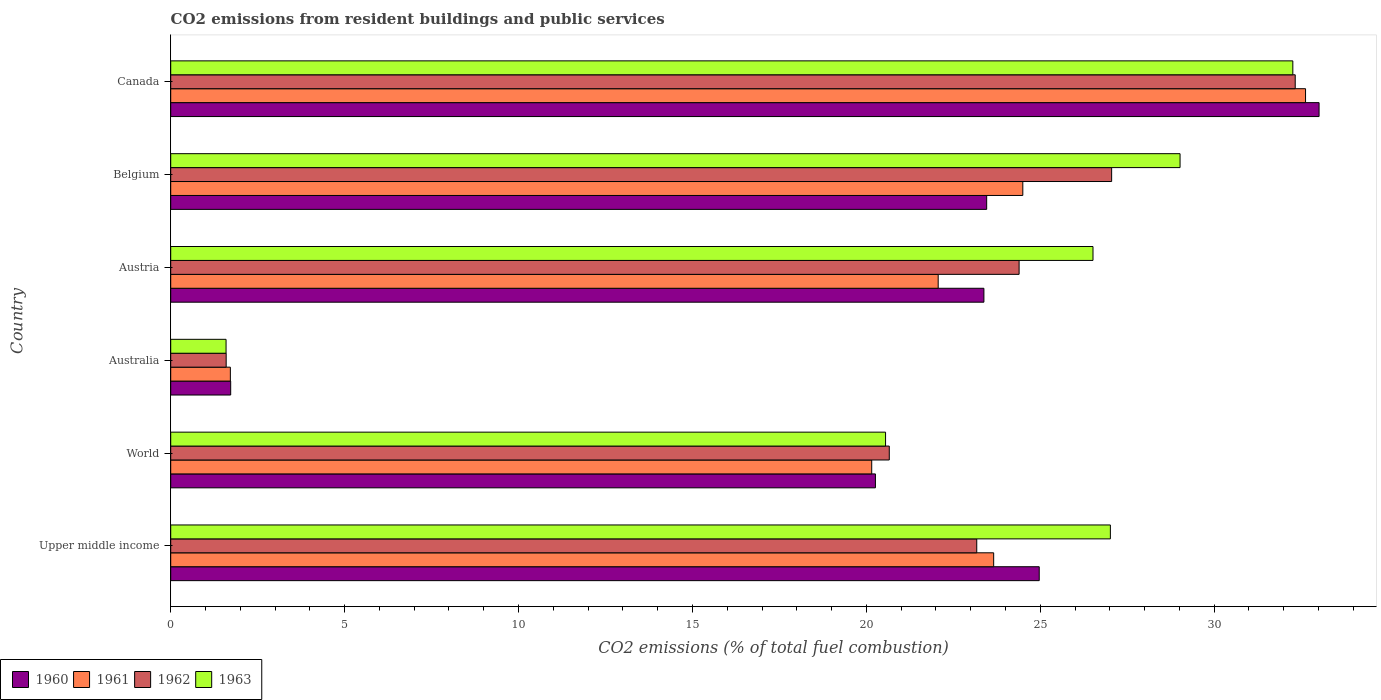How many different coloured bars are there?
Your answer should be compact. 4. How many groups of bars are there?
Provide a succinct answer. 6. Are the number of bars on each tick of the Y-axis equal?
Provide a short and direct response. Yes. How many bars are there on the 1st tick from the top?
Offer a terse response. 4. How many bars are there on the 4th tick from the bottom?
Your response must be concise. 4. What is the total CO2 emitted in 1963 in Canada?
Provide a short and direct response. 32.26. Across all countries, what is the maximum total CO2 emitted in 1961?
Give a very brief answer. 32.63. Across all countries, what is the minimum total CO2 emitted in 1961?
Make the answer very short. 1.71. In which country was the total CO2 emitted in 1961 minimum?
Your answer should be compact. Australia. What is the total total CO2 emitted in 1960 in the graph?
Your answer should be very brief. 126.81. What is the difference between the total CO2 emitted in 1961 in Austria and that in Canada?
Your answer should be very brief. -10.56. What is the difference between the total CO2 emitted in 1961 in Australia and the total CO2 emitted in 1962 in Canada?
Ensure brevity in your answer.  -30.61. What is the average total CO2 emitted in 1960 per country?
Offer a terse response. 21.13. What is the difference between the total CO2 emitted in 1963 and total CO2 emitted in 1960 in Upper middle income?
Give a very brief answer. 2.05. What is the ratio of the total CO2 emitted in 1960 in Austria to that in Belgium?
Provide a short and direct response. 1. Is the total CO2 emitted in 1963 in Austria less than that in Upper middle income?
Give a very brief answer. Yes. What is the difference between the highest and the second highest total CO2 emitted in 1961?
Provide a succinct answer. 8.13. What is the difference between the highest and the lowest total CO2 emitted in 1963?
Your answer should be compact. 30.67. What does the 2nd bar from the top in Belgium represents?
Provide a succinct answer. 1962. Is it the case that in every country, the sum of the total CO2 emitted in 1963 and total CO2 emitted in 1962 is greater than the total CO2 emitted in 1961?
Offer a terse response. Yes. How many bars are there?
Give a very brief answer. 24. How many countries are there in the graph?
Ensure brevity in your answer.  6. Are the values on the major ticks of X-axis written in scientific E-notation?
Make the answer very short. No. Does the graph contain grids?
Provide a succinct answer. No. Where does the legend appear in the graph?
Provide a short and direct response. Bottom left. How are the legend labels stacked?
Make the answer very short. Horizontal. What is the title of the graph?
Offer a terse response. CO2 emissions from resident buildings and public services. What is the label or title of the X-axis?
Offer a terse response. CO2 emissions (% of total fuel combustion). What is the CO2 emissions (% of total fuel combustion) in 1960 in Upper middle income?
Your answer should be compact. 24.97. What is the CO2 emissions (% of total fuel combustion) in 1961 in Upper middle income?
Your answer should be very brief. 23.66. What is the CO2 emissions (% of total fuel combustion) of 1962 in Upper middle income?
Offer a terse response. 23.17. What is the CO2 emissions (% of total fuel combustion) in 1963 in Upper middle income?
Keep it short and to the point. 27.01. What is the CO2 emissions (% of total fuel combustion) in 1960 in World?
Make the answer very short. 20.26. What is the CO2 emissions (% of total fuel combustion) of 1961 in World?
Your answer should be compact. 20.15. What is the CO2 emissions (% of total fuel combustion) in 1962 in World?
Your answer should be compact. 20.66. What is the CO2 emissions (% of total fuel combustion) of 1963 in World?
Offer a very short reply. 20.55. What is the CO2 emissions (% of total fuel combustion) of 1960 in Australia?
Provide a succinct answer. 1.72. What is the CO2 emissions (% of total fuel combustion) in 1961 in Australia?
Keep it short and to the point. 1.71. What is the CO2 emissions (% of total fuel combustion) in 1962 in Australia?
Give a very brief answer. 1.59. What is the CO2 emissions (% of total fuel combustion) in 1963 in Australia?
Provide a succinct answer. 1.59. What is the CO2 emissions (% of total fuel combustion) in 1960 in Austria?
Give a very brief answer. 23.38. What is the CO2 emissions (% of total fuel combustion) of 1961 in Austria?
Provide a short and direct response. 22.06. What is the CO2 emissions (% of total fuel combustion) in 1962 in Austria?
Ensure brevity in your answer.  24.39. What is the CO2 emissions (% of total fuel combustion) of 1963 in Austria?
Ensure brevity in your answer.  26.52. What is the CO2 emissions (% of total fuel combustion) in 1960 in Belgium?
Offer a terse response. 23.46. What is the CO2 emissions (% of total fuel combustion) in 1961 in Belgium?
Offer a very short reply. 24.5. What is the CO2 emissions (% of total fuel combustion) of 1962 in Belgium?
Your answer should be very brief. 27.05. What is the CO2 emissions (% of total fuel combustion) in 1963 in Belgium?
Your answer should be very brief. 29.02. What is the CO2 emissions (% of total fuel combustion) in 1960 in Canada?
Your answer should be compact. 33.01. What is the CO2 emissions (% of total fuel combustion) in 1961 in Canada?
Keep it short and to the point. 32.63. What is the CO2 emissions (% of total fuel combustion) of 1962 in Canada?
Keep it short and to the point. 32.33. What is the CO2 emissions (% of total fuel combustion) of 1963 in Canada?
Your response must be concise. 32.26. Across all countries, what is the maximum CO2 emissions (% of total fuel combustion) of 1960?
Offer a very short reply. 33.01. Across all countries, what is the maximum CO2 emissions (% of total fuel combustion) of 1961?
Provide a succinct answer. 32.63. Across all countries, what is the maximum CO2 emissions (% of total fuel combustion) of 1962?
Give a very brief answer. 32.33. Across all countries, what is the maximum CO2 emissions (% of total fuel combustion) of 1963?
Your answer should be very brief. 32.26. Across all countries, what is the minimum CO2 emissions (% of total fuel combustion) of 1960?
Your answer should be very brief. 1.72. Across all countries, what is the minimum CO2 emissions (% of total fuel combustion) of 1961?
Your answer should be very brief. 1.71. Across all countries, what is the minimum CO2 emissions (% of total fuel combustion) of 1962?
Your answer should be compact. 1.59. Across all countries, what is the minimum CO2 emissions (% of total fuel combustion) of 1963?
Keep it short and to the point. 1.59. What is the total CO2 emissions (% of total fuel combustion) of 1960 in the graph?
Your response must be concise. 126.81. What is the total CO2 emissions (% of total fuel combustion) of 1961 in the graph?
Your answer should be very brief. 124.72. What is the total CO2 emissions (% of total fuel combustion) of 1962 in the graph?
Offer a very short reply. 129.2. What is the total CO2 emissions (% of total fuel combustion) in 1963 in the graph?
Your answer should be very brief. 136.95. What is the difference between the CO2 emissions (% of total fuel combustion) of 1960 in Upper middle income and that in World?
Make the answer very short. 4.71. What is the difference between the CO2 emissions (% of total fuel combustion) of 1961 in Upper middle income and that in World?
Ensure brevity in your answer.  3.51. What is the difference between the CO2 emissions (% of total fuel combustion) in 1962 in Upper middle income and that in World?
Your response must be concise. 2.52. What is the difference between the CO2 emissions (% of total fuel combustion) in 1963 in Upper middle income and that in World?
Your answer should be compact. 6.46. What is the difference between the CO2 emissions (% of total fuel combustion) of 1960 in Upper middle income and that in Australia?
Offer a terse response. 23.25. What is the difference between the CO2 emissions (% of total fuel combustion) of 1961 in Upper middle income and that in Australia?
Provide a short and direct response. 21.95. What is the difference between the CO2 emissions (% of total fuel combustion) of 1962 in Upper middle income and that in Australia?
Offer a very short reply. 21.58. What is the difference between the CO2 emissions (% of total fuel combustion) of 1963 in Upper middle income and that in Australia?
Provide a succinct answer. 25.42. What is the difference between the CO2 emissions (% of total fuel combustion) of 1960 in Upper middle income and that in Austria?
Your response must be concise. 1.59. What is the difference between the CO2 emissions (% of total fuel combustion) of 1961 in Upper middle income and that in Austria?
Make the answer very short. 1.6. What is the difference between the CO2 emissions (% of total fuel combustion) of 1962 in Upper middle income and that in Austria?
Your response must be concise. -1.22. What is the difference between the CO2 emissions (% of total fuel combustion) of 1963 in Upper middle income and that in Austria?
Your answer should be compact. 0.5. What is the difference between the CO2 emissions (% of total fuel combustion) of 1960 in Upper middle income and that in Belgium?
Ensure brevity in your answer.  1.51. What is the difference between the CO2 emissions (% of total fuel combustion) in 1961 in Upper middle income and that in Belgium?
Offer a very short reply. -0.84. What is the difference between the CO2 emissions (% of total fuel combustion) in 1962 in Upper middle income and that in Belgium?
Provide a short and direct response. -3.88. What is the difference between the CO2 emissions (% of total fuel combustion) in 1963 in Upper middle income and that in Belgium?
Your answer should be compact. -2. What is the difference between the CO2 emissions (% of total fuel combustion) in 1960 in Upper middle income and that in Canada?
Provide a short and direct response. -8.05. What is the difference between the CO2 emissions (% of total fuel combustion) of 1961 in Upper middle income and that in Canada?
Make the answer very short. -8.97. What is the difference between the CO2 emissions (% of total fuel combustion) in 1962 in Upper middle income and that in Canada?
Offer a very short reply. -9.16. What is the difference between the CO2 emissions (% of total fuel combustion) of 1963 in Upper middle income and that in Canada?
Provide a short and direct response. -5.25. What is the difference between the CO2 emissions (% of total fuel combustion) in 1960 in World and that in Australia?
Offer a very short reply. 18.54. What is the difference between the CO2 emissions (% of total fuel combustion) of 1961 in World and that in Australia?
Offer a very short reply. 18.44. What is the difference between the CO2 emissions (% of total fuel combustion) in 1962 in World and that in Australia?
Offer a terse response. 19.06. What is the difference between the CO2 emissions (% of total fuel combustion) in 1963 in World and that in Australia?
Provide a succinct answer. 18.96. What is the difference between the CO2 emissions (% of total fuel combustion) in 1960 in World and that in Austria?
Give a very brief answer. -3.12. What is the difference between the CO2 emissions (% of total fuel combustion) in 1961 in World and that in Austria?
Give a very brief answer. -1.91. What is the difference between the CO2 emissions (% of total fuel combustion) of 1962 in World and that in Austria?
Make the answer very short. -3.73. What is the difference between the CO2 emissions (% of total fuel combustion) of 1963 in World and that in Austria?
Give a very brief answer. -5.96. What is the difference between the CO2 emissions (% of total fuel combustion) in 1960 in World and that in Belgium?
Your response must be concise. -3.2. What is the difference between the CO2 emissions (% of total fuel combustion) in 1961 in World and that in Belgium?
Keep it short and to the point. -4.34. What is the difference between the CO2 emissions (% of total fuel combustion) of 1962 in World and that in Belgium?
Your response must be concise. -6.39. What is the difference between the CO2 emissions (% of total fuel combustion) in 1963 in World and that in Belgium?
Offer a very short reply. -8.47. What is the difference between the CO2 emissions (% of total fuel combustion) in 1960 in World and that in Canada?
Your answer should be very brief. -12.75. What is the difference between the CO2 emissions (% of total fuel combustion) of 1961 in World and that in Canada?
Your answer should be compact. -12.47. What is the difference between the CO2 emissions (% of total fuel combustion) of 1962 in World and that in Canada?
Ensure brevity in your answer.  -11.67. What is the difference between the CO2 emissions (% of total fuel combustion) in 1963 in World and that in Canada?
Your answer should be very brief. -11.71. What is the difference between the CO2 emissions (% of total fuel combustion) in 1960 in Australia and that in Austria?
Keep it short and to the point. -21.65. What is the difference between the CO2 emissions (% of total fuel combustion) of 1961 in Australia and that in Austria?
Keep it short and to the point. -20.35. What is the difference between the CO2 emissions (% of total fuel combustion) in 1962 in Australia and that in Austria?
Give a very brief answer. -22.8. What is the difference between the CO2 emissions (% of total fuel combustion) of 1963 in Australia and that in Austria?
Your response must be concise. -24.92. What is the difference between the CO2 emissions (% of total fuel combustion) in 1960 in Australia and that in Belgium?
Offer a terse response. -21.73. What is the difference between the CO2 emissions (% of total fuel combustion) in 1961 in Australia and that in Belgium?
Ensure brevity in your answer.  -22.78. What is the difference between the CO2 emissions (% of total fuel combustion) in 1962 in Australia and that in Belgium?
Give a very brief answer. -25.46. What is the difference between the CO2 emissions (% of total fuel combustion) in 1963 in Australia and that in Belgium?
Provide a short and direct response. -27.43. What is the difference between the CO2 emissions (% of total fuel combustion) in 1960 in Australia and that in Canada?
Your response must be concise. -31.29. What is the difference between the CO2 emissions (% of total fuel combustion) of 1961 in Australia and that in Canada?
Keep it short and to the point. -30.91. What is the difference between the CO2 emissions (% of total fuel combustion) of 1962 in Australia and that in Canada?
Your response must be concise. -30.73. What is the difference between the CO2 emissions (% of total fuel combustion) in 1963 in Australia and that in Canada?
Give a very brief answer. -30.67. What is the difference between the CO2 emissions (% of total fuel combustion) in 1960 in Austria and that in Belgium?
Ensure brevity in your answer.  -0.08. What is the difference between the CO2 emissions (% of total fuel combustion) in 1961 in Austria and that in Belgium?
Your response must be concise. -2.43. What is the difference between the CO2 emissions (% of total fuel combustion) of 1962 in Austria and that in Belgium?
Offer a terse response. -2.66. What is the difference between the CO2 emissions (% of total fuel combustion) of 1963 in Austria and that in Belgium?
Make the answer very short. -2.5. What is the difference between the CO2 emissions (% of total fuel combustion) of 1960 in Austria and that in Canada?
Your answer should be very brief. -9.64. What is the difference between the CO2 emissions (% of total fuel combustion) in 1961 in Austria and that in Canada?
Make the answer very short. -10.56. What is the difference between the CO2 emissions (% of total fuel combustion) in 1962 in Austria and that in Canada?
Give a very brief answer. -7.94. What is the difference between the CO2 emissions (% of total fuel combustion) in 1963 in Austria and that in Canada?
Offer a very short reply. -5.74. What is the difference between the CO2 emissions (% of total fuel combustion) of 1960 in Belgium and that in Canada?
Your answer should be very brief. -9.56. What is the difference between the CO2 emissions (% of total fuel combustion) in 1961 in Belgium and that in Canada?
Your answer should be compact. -8.13. What is the difference between the CO2 emissions (% of total fuel combustion) in 1962 in Belgium and that in Canada?
Provide a short and direct response. -5.28. What is the difference between the CO2 emissions (% of total fuel combustion) of 1963 in Belgium and that in Canada?
Offer a very short reply. -3.24. What is the difference between the CO2 emissions (% of total fuel combustion) in 1960 in Upper middle income and the CO2 emissions (% of total fuel combustion) in 1961 in World?
Your answer should be compact. 4.82. What is the difference between the CO2 emissions (% of total fuel combustion) in 1960 in Upper middle income and the CO2 emissions (% of total fuel combustion) in 1962 in World?
Offer a terse response. 4.31. What is the difference between the CO2 emissions (% of total fuel combustion) of 1960 in Upper middle income and the CO2 emissions (% of total fuel combustion) of 1963 in World?
Make the answer very short. 4.42. What is the difference between the CO2 emissions (% of total fuel combustion) of 1961 in Upper middle income and the CO2 emissions (% of total fuel combustion) of 1962 in World?
Ensure brevity in your answer.  3. What is the difference between the CO2 emissions (% of total fuel combustion) in 1961 in Upper middle income and the CO2 emissions (% of total fuel combustion) in 1963 in World?
Offer a very short reply. 3.11. What is the difference between the CO2 emissions (% of total fuel combustion) in 1962 in Upper middle income and the CO2 emissions (% of total fuel combustion) in 1963 in World?
Provide a short and direct response. 2.62. What is the difference between the CO2 emissions (% of total fuel combustion) of 1960 in Upper middle income and the CO2 emissions (% of total fuel combustion) of 1961 in Australia?
Provide a short and direct response. 23.26. What is the difference between the CO2 emissions (% of total fuel combustion) in 1960 in Upper middle income and the CO2 emissions (% of total fuel combustion) in 1962 in Australia?
Provide a succinct answer. 23.38. What is the difference between the CO2 emissions (% of total fuel combustion) of 1960 in Upper middle income and the CO2 emissions (% of total fuel combustion) of 1963 in Australia?
Ensure brevity in your answer.  23.38. What is the difference between the CO2 emissions (% of total fuel combustion) of 1961 in Upper middle income and the CO2 emissions (% of total fuel combustion) of 1962 in Australia?
Offer a very short reply. 22.07. What is the difference between the CO2 emissions (% of total fuel combustion) in 1961 in Upper middle income and the CO2 emissions (% of total fuel combustion) in 1963 in Australia?
Offer a terse response. 22.07. What is the difference between the CO2 emissions (% of total fuel combustion) in 1962 in Upper middle income and the CO2 emissions (% of total fuel combustion) in 1963 in Australia?
Your answer should be very brief. 21.58. What is the difference between the CO2 emissions (% of total fuel combustion) of 1960 in Upper middle income and the CO2 emissions (% of total fuel combustion) of 1961 in Austria?
Offer a terse response. 2.9. What is the difference between the CO2 emissions (% of total fuel combustion) of 1960 in Upper middle income and the CO2 emissions (% of total fuel combustion) of 1962 in Austria?
Provide a succinct answer. 0.58. What is the difference between the CO2 emissions (% of total fuel combustion) in 1960 in Upper middle income and the CO2 emissions (% of total fuel combustion) in 1963 in Austria?
Offer a terse response. -1.55. What is the difference between the CO2 emissions (% of total fuel combustion) in 1961 in Upper middle income and the CO2 emissions (% of total fuel combustion) in 1962 in Austria?
Provide a short and direct response. -0.73. What is the difference between the CO2 emissions (% of total fuel combustion) of 1961 in Upper middle income and the CO2 emissions (% of total fuel combustion) of 1963 in Austria?
Offer a very short reply. -2.86. What is the difference between the CO2 emissions (% of total fuel combustion) in 1962 in Upper middle income and the CO2 emissions (% of total fuel combustion) in 1963 in Austria?
Offer a very short reply. -3.34. What is the difference between the CO2 emissions (% of total fuel combustion) of 1960 in Upper middle income and the CO2 emissions (% of total fuel combustion) of 1961 in Belgium?
Keep it short and to the point. 0.47. What is the difference between the CO2 emissions (% of total fuel combustion) of 1960 in Upper middle income and the CO2 emissions (% of total fuel combustion) of 1962 in Belgium?
Your answer should be very brief. -2.08. What is the difference between the CO2 emissions (% of total fuel combustion) in 1960 in Upper middle income and the CO2 emissions (% of total fuel combustion) in 1963 in Belgium?
Make the answer very short. -4.05. What is the difference between the CO2 emissions (% of total fuel combustion) of 1961 in Upper middle income and the CO2 emissions (% of total fuel combustion) of 1962 in Belgium?
Your answer should be very brief. -3.39. What is the difference between the CO2 emissions (% of total fuel combustion) of 1961 in Upper middle income and the CO2 emissions (% of total fuel combustion) of 1963 in Belgium?
Provide a succinct answer. -5.36. What is the difference between the CO2 emissions (% of total fuel combustion) of 1962 in Upper middle income and the CO2 emissions (% of total fuel combustion) of 1963 in Belgium?
Your answer should be very brief. -5.85. What is the difference between the CO2 emissions (% of total fuel combustion) in 1960 in Upper middle income and the CO2 emissions (% of total fuel combustion) in 1961 in Canada?
Ensure brevity in your answer.  -7.66. What is the difference between the CO2 emissions (% of total fuel combustion) in 1960 in Upper middle income and the CO2 emissions (% of total fuel combustion) in 1962 in Canada?
Offer a very short reply. -7.36. What is the difference between the CO2 emissions (% of total fuel combustion) in 1960 in Upper middle income and the CO2 emissions (% of total fuel combustion) in 1963 in Canada?
Ensure brevity in your answer.  -7.29. What is the difference between the CO2 emissions (% of total fuel combustion) of 1961 in Upper middle income and the CO2 emissions (% of total fuel combustion) of 1962 in Canada?
Offer a terse response. -8.67. What is the difference between the CO2 emissions (% of total fuel combustion) in 1961 in Upper middle income and the CO2 emissions (% of total fuel combustion) in 1963 in Canada?
Your response must be concise. -8.6. What is the difference between the CO2 emissions (% of total fuel combustion) in 1962 in Upper middle income and the CO2 emissions (% of total fuel combustion) in 1963 in Canada?
Offer a very short reply. -9.09. What is the difference between the CO2 emissions (% of total fuel combustion) of 1960 in World and the CO2 emissions (% of total fuel combustion) of 1961 in Australia?
Your answer should be compact. 18.55. What is the difference between the CO2 emissions (% of total fuel combustion) of 1960 in World and the CO2 emissions (% of total fuel combustion) of 1962 in Australia?
Give a very brief answer. 18.67. What is the difference between the CO2 emissions (% of total fuel combustion) of 1960 in World and the CO2 emissions (% of total fuel combustion) of 1963 in Australia?
Offer a terse response. 18.67. What is the difference between the CO2 emissions (% of total fuel combustion) in 1961 in World and the CO2 emissions (% of total fuel combustion) in 1962 in Australia?
Provide a short and direct response. 18.56. What is the difference between the CO2 emissions (% of total fuel combustion) of 1961 in World and the CO2 emissions (% of total fuel combustion) of 1963 in Australia?
Provide a succinct answer. 18.56. What is the difference between the CO2 emissions (% of total fuel combustion) of 1962 in World and the CO2 emissions (% of total fuel combustion) of 1963 in Australia?
Keep it short and to the point. 19.07. What is the difference between the CO2 emissions (% of total fuel combustion) in 1960 in World and the CO2 emissions (% of total fuel combustion) in 1961 in Austria?
Keep it short and to the point. -1.8. What is the difference between the CO2 emissions (% of total fuel combustion) in 1960 in World and the CO2 emissions (% of total fuel combustion) in 1962 in Austria?
Give a very brief answer. -4.13. What is the difference between the CO2 emissions (% of total fuel combustion) in 1960 in World and the CO2 emissions (% of total fuel combustion) in 1963 in Austria?
Keep it short and to the point. -6.26. What is the difference between the CO2 emissions (% of total fuel combustion) of 1961 in World and the CO2 emissions (% of total fuel combustion) of 1962 in Austria?
Keep it short and to the point. -4.24. What is the difference between the CO2 emissions (% of total fuel combustion) of 1961 in World and the CO2 emissions (% of total fuel combustion) of 1963 in Austria?
Your answer should be compact. -6.36. What is the difference between the CO2 emissions (% of total fuel combustion) in 1962 in World and the CO2 emissions (% of total fuel combustion) in 1963 in Austria?
Your answer should be very brief. -5.86. What is the difference between the CO2 emissions (% of total fuel combustion) in 1960 in World and the CO2 emissions (% of total fuel combustion) in 1961 in Belgium?
Provide a short and direct response. -4.24. What is the difference between the CO2 emissions (% of total fuel combustion) of 1960 in World and the CO2 emissions (% of total fuel combustion) of 1962 in Belgium?
Offer a very short reply. -6.79. What is the difference between the CO2 emissions (% of total fuel combustion) of 1960 in World and the CO2 emissions (% of total fuel combustion) of 1963 in Belgium?
Ensure brevity in your answer.  -8.76. What is the difference between the CO2 emissions (% of total fuel combustion) of 1961 in World and the CO2 emissions (% of total fuel combustion) of 1962 in Belgium?
Offer a terse response. -6.9. What is the difference between the CO2 emissions (% of total fuel combustion) of 1961 in World and the CO2 emissions (% of total fuel combustion) of 1963 in Belgium?
Ensure brevity in your answer.  -8.87. What is the difference between the CO2 emissions (% of total fuel combustion) of 1962 in World and the CO2 emissions (% of total fuel combustion) of 1963 in Belgium?
Your answer should be compact. -8.36. What is the difference between the CO2 emissions (% of total fuel combustion) of 1960 in World and the CO2 emissions (% of total fuel combustion) of 1961 in Canada?
Keep it short and to the point. -12.37. What is the difference between the CO2 emissions (% of total fuel combustion) in 1960 in World and the CO2 emissions (% of total fuel combustion) in 1962 in Canada?
Make the answer very short. -12.07. What is the difference between the CO2 emissions (% of total fuel combustion) of 1960 in World and the CO2 emissions (% of total fuel combustion) of 1963 in Canada?
Keep it short and to the point. -12. What is the difference between the CO2 emissions (% of total fuel combustion) of 1961 in World and the CO2 emissions (% of total fuel combustion) of 1962 in Canada?
Your answer should be very brief. -12.18. What is the difference between the CO2 emissions (% of total fuel combustion) in 1961 in World and the CO2 emissions (% of total fuel combustion) in 1963 in Canada?
Your answer should be compact. -12.11. What is the difference between the CO2 emissions (% of total fuel combustion) of 1962 in World and the CO2 emissions (% of total fuel combustion) of 1963 in Canada?
Your answer should be compact. -11.6. What is the difference between the CO2 emissions (% of total fuel combustion) in 1960 in Australia and the CO2 emissions (% of total fuel combustion) in 1961 in Austria?
Your response must be concise. -20.34. What is the difference between the CO2 emissions (% of total fuel combustion) in 1960 in Australia and the CO2 emissions (% of total fuel combustion) in 1962 in Austria?
Your answer should be compact. -22.67. What is the difference between the CO2 emissions (% of total fuel combustion) of 1960 in Australia and the CO2 emissions (% of total fuel combustion) of 1963 in Austria?
Provide a succinct answer. -24.79. What is the difference between the CO2 emissions (% of total fuel combustion) of 1961 in Australia and the CO2 emissions (% of total fuel combustion) of 1962 in Austria?
Offer a very short reply. -22.68. What is the difference between the CO2 emissions (% of total fuel combustion) in 1961 in Australia and the CO2 emissions (% of total fuel combustion) in 1963 in Austria?
Your answer should be compact. -24.8. What is the difference between the CO2 emissions (% of total fuel combustion) of 1962 in Australia and the CO2 emissions (% of total fuel combustion) of 1963 in Austria?
Ensure brevity in your answer.  -24.92. What is the difference between the CO2 emissions (% of total fuel combustion) in 1960 in Australia and the CO2 emissions (% of total fuel combustion) in 1961 in Belgium?
Ensure brevity in your answer.  -22.77. What is the difference between the CO2 emissions (% of total fuel combustion) of 1960 in Australia and the CO2 emissions (% of total fuel combustion) of 1962 in Belgium?
Make the answer very short. -25.33. What is the difference between the CO2 emissions (% of total fuel combustion) in 1960 in Australia and the CO2 emissions (% of total fuel combustion) in 1963 in Belgium?
Your response must be concise. -27.29. What is the difference between the CO2 emissions (% of total fuel combustion) of 1961 in Australia and the CO2 emissions (% of total fuel combustion) of 1962 in Belgium?
Offer a terse response. -25.34. What is the difference between the CO2 emissions (% of total fuel combustion) of 1961 in Australia and the CO2 emissions (% of total fuel combustion) of 1963 in Belgium?
Provide a short and direct response. -27.3. What is the difference between the CO2 emissions (% of total fuel combustion) of 1962 in Australia and the CO2 emissions (% of total fuel combustion) of 1963 in Belgium?
Give a very brief answer. -27.42. What is the difference between the CO2 emissions (% of total fuel combustion) of 1960 in Australia and the CO2 emissions (% of total fuel combustion) of 1961 in Canada?
Offer a very short reply. -30.9. What is the difference between the CO2 emissions (% of total fuel combustion) of 1960 in Australia and the CO2 emissions (% of total fuel combustion) of 1962 in Canada?
Provide a succinct answer. -30.61. What is the difference between the CO2 emissions (% of total fuel combustion) of 1960 in Australia and the CO2 emissions (% of total fuel combustion) of 1963 in Canada?
Provide a succinct answer. -30.54. What is the difference between the CO2 emissions (% of total fuel combustion) in 1961 in Australia and the CO2 emissions (% of total fuel combustion) in 1962 in Canada?
Provide a succinct answer. -30.61. What is the difference between the CO2 emissions (% of total fuel combustion) of 1961 in Australia and the CO2 emissions (% of total fuel combustion) of 1963 in Canada?
Offer a terse response. -30.55. What is the difference between the CO2 emissions (% of total fuel combustion) of 1962 in Australia and the CO2 emissions (% of total fuel combustion) of 1963 in Canada?
Provide a short and direct response. -30.67. What is the difference between the CO2 emissions (% of total fuel combustion) in 1960 in Austria and the CO2 emissions (% of total fuel combustion) in 1961 in Belgium?
Give a very brief answer. -1.12. What is the difference between the CO2 emissions (% of total fuel combustion) in 1960 in Austria and the CO2 emissions (% of total fuel combustion) in 1962 in Belgium?
Provide a succinct answer. -3.67. What is the difference between the CO2 emissions (% of total fuel combustion) in 1960 in Austria and the CO2 emissions (% of total fuel combustion) in 1963 in Belgium?
Make the answer very short. -5.64. What is the difference between the CO2 emissions (% of total fuel combustion) in 1961 in Austria and the CO2 emissions (% of total fuel combustion) in 1962 in Belgium?
Your answer should be compact. -4.99. What is the difference between the CO2 emissions (% of total fuel combustion) of 1961 in Austria and the CO2 emissions (% of total fuel combustion) of 1963 in Belgium?
Make the answer very short. -6.95. What is the difference between the CO2 emissions (% of total fuel combustion) of 1962 in Austria and the CO2 emissions (% of total fuel combustion) of 1963 in Belgium?
Your answer should be compact. -4.63. What is the difference between the CO2 emissions (% of total fuel combustion) in 1960 in Austria and the CO2 emissions (% of total fuel combustion) in 1961 in Canada?
Give a very brief answer. -9.25. What is the difference between the CO2 emissions (% of total fuel combustion) of 1960 in Austria and the CO2 emissions (% of total fuel combustion) of 1962 in Canada?
Your answer should be very brief. -8.95. What is the difference between the CO2 emissions (% of total fuel combustion) in 1960 in Austria and the CO2 emissions (% of total fuel combustion) in 1963 in Canada?
Provide a succinct answer. -8.88. What is the difference between the CO2 emissions (% of total fuel combustion) of 1961 in Austria and the CO2 emissions (% of total fuel combustion) of 1962 in Canada?
Your answer should be very brief. -10.26. What is the difference between the CO2 emissions (% of total fuel combustion) of 1961 in Austria and the CO2 emissions (% of total fuel combustion) of 1963 in Canada?
Your answer should be compact. -10.2. What is the difference between the CO2 emissions (% of total fuel combustion) in 1962 in Austria and the CO2 emissions (% of total fuel combustion) in 1963 in Canada?
Offer a terse response. -7.87. What is the difference between the CO2 emissions (% of total fuel combustion) in 1960 in Belgium and the CO2 emissions (% of total fuel combustion) in 1961 in Canada?
Give a very brief answer. -9.17. What is the difference between the CO2 emissions (% of total fuel combustion) of 1960 in Belgium and the CO2 emissions (% of total fuel combustion) of 1962 in Canada?
Ensure brevity in your answer.  -8.87. What is the difference between the CO2 emissions (% of total fuel combustion) in 1960 in Belgium and the CO2 emissions (% of total fuel combustion) in 1963 in Canada?
Keep it short and to the point. -8.8. What is the difference between the CO2 emissions (% of total fuel combustion) of 1961 in Belgium and the CO2 emissions (% of total fuel combustion) of 1962 in Canada?
Your answer should be compact. -7.83. What is the difference between the CO2 emissions (% of total fuel combustion) in 1961 in Belgium and the CO2 emissions (% of total fuel combustion) in 1963 in Canada?
Keep it short and to the point. -7.76. What is the difference between the CO2 emissions (% of total fuel combustion) of 1962 in Belgium and the CO2 emissions (% of total fuel combustion) of 1963 in Canada?
Provide a short and direct response. -5.21. What is the average CO2 emissions (% of total fuel combustion) in 1960 per country?
Make the answer very short. 21.13. What is the average CO2 emissions (% of total fuel combustion) in 1961 per country?
Provide a succinct answer. 20.79. What is the average CO2 emissions (% of total fuel combustion) in 1962 per country?
Give a very brief answer. 21.53. What is the average CO2 emissions (% of total fuel combustion) in 1963 per country?
Make the answer very short. 22.83. What is the difference between the CO2 emissions (% of total fuel combustion) of 1960 and CO2 emissions (% of total fuel combustion) of 1961 in Upper middle income?
Your answer should be very brief. 1.31. What is the difference between the CO2 emissions (% of total fuel combustion) of 1960 and CO2 emissions (% of total fuel combustion) of 1962 in Upper middle income?
Your response must be concise. 1.8. What is the difference between the CO2 emissions (% of total fuel combustion) of 1960 and CO2 emissions (% of total fuel combustion) of 1963 in Upper middle income?
Offer a terse response. -2.05. What is the difference between the CO2 emissions (% of total fuel combustion) of 1961 and CO2 emissions (% of total fuel combustion) of 1962 in Upper middle income?
Make the answer very short. 0.49. What is the difference between the CO2 emissions (% of total fuel combustion) of 1961 and CO2 emissions (% of total fuel combustion) of 1963 in Upper middle income?
Your answer should be compact. -3.35. What is the difference between the CO2 emissions (% of total fuel combustion) of 1962 and CO2 emissions (% of total fuel combustion) of 1963 in Upper middle income?
Ensure brevity in your answer.  -3.84. What is the difference between the CO2 emissions (% of total fuel combustion) of 1960 and CO2 emissions (% of total fuel combustion) of 1961 in World?
Provide a succinct answer. 0.11. What is the difference between the CO2 emissions (% of total fuel combustion) of 1960 and CO2 emissions (% of total fuel combustion) of 1962 in World?
Provide a short and direct response. -0.4. What is the difference between the CO2 emissions (% of total fuel combustion) in 1960 and CO2 emissions (% of total fuel combustion) in 1963 in World?
Ensure brevity in your answer.  -0.29. What is the difference between the CO2 emissions (% of total fuel combustion) in 1961 and CO2 emissions (% of total fuel combustion) in 1962 in World?
Offer a terse response. -0.5. What is the difference between the CO2 emissions (% of total fuel combustion) in 1961 and CO2 emissions (% of total fuel combustion) in 1963 in World?
Your response must be concise. -0.4. What is the difference between the CO2 emissions (% of total fuel combustion) of 1962 and CO2 emissions (% of total fuel combustion) of 1963 in World?
Ensure brevity in your answer.  0.11. What is the difference between the CO2 emissions (% of total fuel combustion) in 1960 and CO2 emissions (% of total fuel combustion) in 1961 in Australia?
Your answer should be very brief. 0.01. What is the difference between the CO2 emissions (% of total fuel combustion) of 1960 and CO2 emissions (% of total fuel combustion) of 1962 in Australia?
Provide a short and direct response. 0.13. What is the difference between the CO2 emissions (% of total fuel combustion) of 1960 and CO2 emissions (% of total fuel combustion) of 1963 in Australia?
Ensure brevity in your answer.  0.13. What is the difference between the CO2 emissions (% of total fuel combustion) in 1961 and CO2 emissions (% of total fuel combustion) in 1962 in Australia?
Your answer should be very brief. 0.12. What is the difference between the CO2 emissions (% of total fuel combustion) in 1961 and CO2 emissions (% of total fuel combustion) in 1963 in Australia?
Your answer should be very brief. 0.12. What is the difference between the CO2 emissions (% of total fuel combustion) in 1962 and CO2 emissions (% of total fuel combustion) in 1963 in Australia?
Keep it short and to the point. 0. What is the difference between the CO2 emissions (% of total fuel combustion) in 1960 and CO2 emissions (% of total fuel combustion) in 1961 in Austria?
Keep it short and to the point. 1.31. What is the difference between the CO2 emissions (% of total fuel combustion) in 1960 and CO2 emissions (% of total fuel combustion) in 1962 in Austria?
Offer a terse response. -1.01. What is the difference between the CO2 emissions (% of total fuel combustion) in 1960 and CO2 emissions (% of total fuel combustion) in 1963 in Austria?
Offer a very short reply. -3.14. What is the difference between the CO2 emissions (% of total fuel combustion) of 1961 and CO2 emissions (% of total fuel combustion) of 1962 in Austria?
Provide a short and direct response. -2.33. What is the difference between the CO2 emissions (% of total fuel combustion) in 1961 and CO2 emissions (% of total fuel combustion) in 1963 in Austria?
Your answer should be very brief. -4.45. What is the difference between the CO2 emissions (% of total fuel combustion) in 1962 and CO2 emissions (% of total fuel combustion) in 1963 in Austria?
Offer a very short reply. -2.12. What is the difference between the CO2 emissions (% of total fuel combustion) of 1960 and CO2 emissions (% of total fuel combustion) of 1961 in Belgium?
Your answer should be very brief. -1.04. What is the difference between the CO2 emissions (% of total fuel combustion) in 1960 and CO2 emissions (% of total fuel combustion) in 1962 in Belgium?
Keep it short and to the point. -3.59. What is the difference between the CO2 emissions (% of total fuel combustion) in 1960 and CO2 emissions (% of total fuel combustion) in 1963 in Belgium?
Keep it short and to the point. -5.56. What is the difference between the CO2 emissions (% of total fuel combustion) of 1961 and CO2 emissions (% of total fuel combustion) of 1962 in Belgium?
Offer a terse response. -2.55. What is the difference between the CO2 emissions (% of total fuel combustion) in 1961 and CO2 emissions (% of total fuel combustion) in 1963 in Belgium?
Make the answer very short. -4.52. What is the difference between the CO2 emissions (% of total fuel combustion) in 1962 and CO2 emissions (% of total fuel combustion) in 1963 in Belgium?
Keep it short and to the point. -1.97. What is the difference between the CO2 emissions (% of total fuel combustion) in 1960 and CO2 emissions (% of total fuel combustion) in 1961 in Canada?
Your answer should be compact. 0.39. What is the difference between the CO2 emissions (% of total fuel combustion) in 1960 and CO2 emissions (% of total fuel combustion) in 1962 in Canada?
Make the answer very short. 0.69. What is the difference between the CO2 emissions (% of total fuel combustion) of 1960 and CO2 emissions (% of total fuel combustion) of 1963 in Canada?
Your answer should be very brief. 0.75. What is the difference between the CO2 emissions (% of total fuel combustion) in 1961 and CO2 emissions (% of total fuel combustion) in 1962 in Canada?
Give a very brief answer. 0.3. What is the difference between the CO2 emissions (% of total fuel combustion) of 1961 and CO2 emissions (% of total fuel combustion) of 1963 in Canada?
Keep it short and to the point. 0.37. What is the difference between the CO2 emissions (% of total fuel combustion) in 1962 and CO2 emissions (% of total fuel combustion) in 1963 in Canada?
Provide a succinct answer. 0.07. What is the ratio of the CO2 emissions (% of total fuel combustion) of 1960 in Upper middle income to that in World?
Offer a terse response. 1.23. What is the ratio of the CO2 emissions (% of total fuel combustion) of 1961 in Upper middle income to that in World?
Provide a short and direct response. 1.17. What is the ratio of the CO2 emissions (% of total fuel combustion) of 1962 in Upper middle income to that in World?
Your answer should be very brief. 1.12. What is the ratio of the CO2 emissions (% of total fuel combustion) in 1963 in Upper middle income to that in World?
Offer a very short reply. 1.31. What is the ratio of the CO2 emissions (% of total fuel combustion) of 1960 in Upper middle income to that in Australia?
Make the answer very short. 14.48. What is the ratio of the CO2 emissions (% of total fuel combustion) of 1961 in Upper middle income to that in Australia?
Your answer should be very brief. 13.8. What is the ratio of the CO2 emissions (% of total fuel combustion) in 1962 in Upper middle income to that in Australia?
Offer a terse response. 14.53. What is the ratio of the CO2 emissions (% of total fuel combustion) of 1963 in Upper middle income to that in Australia?
Your response must be concise. 16.98. What is the ratio of the CO2 emissions (% of total fuel combustion) in 1960 in Upper middle income to that in Austria?
Ensure brevity in your answer.  1.07. What is the ratio of the CO2 emissions (% of total fuel combustion) of 1961 in Upper middle income to that in Austria?
Provide a short and direct response. 1.07. What is the ratio of the CO2 emissions (% of total fuel combustion) in 1962 in Upper middle income to that in Austria?
Ensure brevity in your answer.  0.95. What is the ratio of the CO2 emissions (% of total fuel combustion) in 1963 in Upper middle income to that in Austria?
Provide a succinct answer. 1.02. What is the ratio of the CO2 emissions (% of total fuel combustion) in 1960 in Upper middle income to that in Belgium?
Keep it short and to the point. 1.06. What is the ratio of the CO2 emissions (% of total fuel combustion) of 1961 in Upper middle income to that in Belgium?
Offer a terse response. 0.97. What is the ratio of the CO2 emissions (% of total fuel combustion) of 1962 in Upper middle income to that in Belgium?
Offer a very short reply. 0.86. What is the ratio of the CO2 emissions (% of total fuel combustion) of 1963 in Upper middle income to that in Belgium?
Your response must be concise. 0.93. What is the ratio of the CO2 emissions (% of total fuel combustion) of 1960 in Upper middle income to that in Canada?
Your response must be concise. 0.76. What is the ratio of the CO2 emissions (% of total fuel combustion) of 1961 in Upper middle income to that in Canada?
Provide a short and direct response. 0.73. What is the ratio of the CO2 emissions (% of total fuel combustion) in 1962 in Upper middle income to that in Canada?
Your answer should be compact. 0.72. What is the ratio of the CO2 emissions (% of total fuel combustion) in 1963 in Upper middle income to that in Canada?
Make the answer very short. 0.84. What is the ratio of the CO2 emissions (% of total fuel combustion) in 1960 in World to that in Australia?
Provide a succinct answer. 11.75. What is the ratio of the CO2 emissions (% of total fuel combustion) in 1961 in World to that in Australia?
Provide a succinct answer. 11.75. What is the ratio of the CO2 emissions (% of total fuel combustion) in 1962 in World to that in Australia?
Provide a succinct answer. 12.96. What is the ratio of the CO2 emissions (% of total fuel combustion) of 1963 in World to that in Australia?
Provide a succinct answer. 12.92. What is the ratio of the CO2 emissions (% of total fuel combustion) in 1960 in World to that in Austria?
Offer a very short reply. 0.87. What is the ratio of the CO2 emissions (% of total fuel combustion) of 1961 in World to that in Austria?
Offer a very short reply. 0.91. What is the ratio of the CO2 emissions (% of total fuel combustion) of 1962 in World to that in Austria?
Make the answer very short. 0.85. What is the ratio of the CO2 emissions (% of total fuel combustion) in 1963 in World to that in Austria?
Provide a short and direct response. 0.78. What is the ratio of the CO2 emissions (% of total fuel combustion) in 1960 in World to that in Belgium?
Your answer should be very brief. 0.86. What is the ratio of the CO2 emissions (% of total fuel combustion) of 1961 in World to that in Belgium?
Make the answer very short. 0.82. What is the ratio of the CO2 emissions (% of total fuel combustion) of 1962 in World to that in Belgium?
Your response must be concise. 0.76. What is the ratio of the CO2 emissions (% of total fuel combustion) of 1963 in World to that in Belgium?
Keep it short and to the point. 0.71. What is the ratio of the CO2 emissions (% of total fuel combustion) of 1960 in World to that in Canada?
Give a very brief answer. 0.61. What is the ratio of the CO2 emissions (% of total fuel combustion) in 1961 in World to that in Canada?
Offer a terse response. 0.62. What is the ratio of the CO2 emissions (% of total fuel combustion) of 1962 in World to that in Canada?
Offer a terse response. 0.64. What is the ratio of the CO2 emissions (% of total fuel combustion) of 1963 in World to that in Canada?
Make the answer very short. 0.64. What is the ratio of the CO2 emissions (% of total fuel combustion) of 1960 in Australia to that in Austria?
Offer a very short reply. 0.07. What is the ratio of the CO2 emissions (% of total fuel combustion) of 1961 in Australia to that in Austria?
Keep it short and to the point. 0.08. What is the ratio of the CO2 emissions (% of total fuel combustion) in 1962 in Australia to that in Austria?
Your response must be concise. 0.07. What is the ratio of the CO2 emissions (% of total fuel combustion) of 1963 in Australia to that in Austria?
Offer a terse response. 0.06. What is the ratio of the CO2 emissions (% of total fuel combustion) of 1960 in Australia to that in Belgium?
Your response must be concise. 0.07. What is the ratio of the CO2 emissions (% of total fuel combustion) in 1961 in Australia to that in Belgium?
Your answer should be very brief. 0.07. What is the ratio of the CO2 emissions (% of total fuel combustion) of 1962 in Australia to that in Belgium?
Provide a succinct answer. 0.06. What is the ratio of the CO2 emissions (% of total fuel combustion) in 1963 in Australia to that in Belgium?
Your response must be concise. 0.05. What is the ratio of the CO2 emissions (% of total fuel combustion) in 1960 in Australia to that in Canada?
Your response must be concise. 0.05. What is the ratio of the CO2 emissions (% of total fuel combustion) in 1961 in Australia to that in Canada?
Offer a very short reply. 0.05. What is the ratio of the CO2 emissions (% of total fuel combustion) of 1962 in Australia to that in Canada?
Provide a short and direct response. 0.05. What is the ratio of the CO2 emissions (% of total fuel combustion) in 1963 in Australia to that in Canada?
Provide a short and direct response. 0.05. What is the ratio of the CO2 emissions (% of total fuel combustion) of 1961 in Austria to that in Belgium?
Offer a very short reply. 0.9. What is the ratio of the CO2 emissions (% of total fuel combustion) in 1962 in Austria to that in Belgium?
Ensure brevity in your answer.  0.9. What is the ratio of the CO2 emissions (% of total fuel combustion) of 1963 in Austria to that in Belgium?
Your answer should be very brief. 0.91. What is the ratio of the CO2 emissions (% of total fuel combustion) in 1960 in Austria to that in Canada?
Your response must be concise. 0.71. What is the ratio of the CO2 emissions (% of total fuel combustion) in 1961 in Austria to that in Canada?
Provide a short and direct response. 0.68. What is the ratio of the CO2 emissions (% of total fuel combustion) of 1962 in Austria to that in Canada?
Offer a terse response. 0.75. What is the ratio of the CO2 emissions (% of total fuel combustion) of 1963 in Austria to that in Canada?
Offer a very short reply. 0.82. What is the ratio of the CO2 emissions (% of total fuel combustion) of 1960 in Belgium to that in Canada?
Give a very brief answer. 0.71. What is the ratio of the CO2 emissions (% of total fuel combustion) in 1961 in Belgium to that in Canada?
Provide a succinct answer. 0.75. What is the ratio of the CO2 emissions (% of total fuel combustion) in 1962 in Belgium to that in Canada?
Your response must be concise. 0.84. What is the ratio of the CO2 emissions (% of total fuel combustion) in 1963 in Belgium to that in Canada?
Your response must be concise. 0.9. What is the difference between the highest and the second highest CO2 emissions (% of total fuel combustion) of 1960?
Give a very brief answer. 8.05. What is the difference between the highest and the second highest CO2 emissions (% of total fuel combustion) of 1961?
Keep it short and to the point. 8.13. What is the difference between the highest and the second highest CO2 emissions (% of total fuel combustion) in 1962?
Your answer should be compact. 5.28. What is the difference between the highest and the second highest CO2 emissions (% of total fuel combustion) of 1963?
Your answer should be compact. 3.24. What is the difference between the highest and the lowest CO2 emissions (% of total fuel combustion) of 1960?
Your answer should be compact. 31.29. What is the difference between the highest and the lowest CO2 emissions (% of total fuel combustion) of 1961?
Offer a terse response. 30.91. What is the difference between the highest and the lowest CO2 emissions (% of total fuel combustion) of 1962?
Provide a succinct answer. 30.73. What is the difference between the highest and the lowest CO2 emissions (% of total fuel combustion) of 1963?
Ensure brevity in your answer.  30.67. 